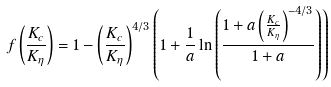Convert formula to latex. <formula><loc_0><loc_0><loc_500><loc_500>f \left ( \frac { K _ { c } } { K _ { \eta } } \right ) = 1 - \left ( \frac { K _ { c } } { K _ { \eta } } \right ) ^ { 4 / 3 } \left ( 1 + \frac { 1 } { a } \ln \left ( \frac { 1 + a \left ( \frac { K _ { c } } { K _ { \eta } } \right ) ^ { - 4 / 3 } } { 1 + a } \right ) \right )</formula> 